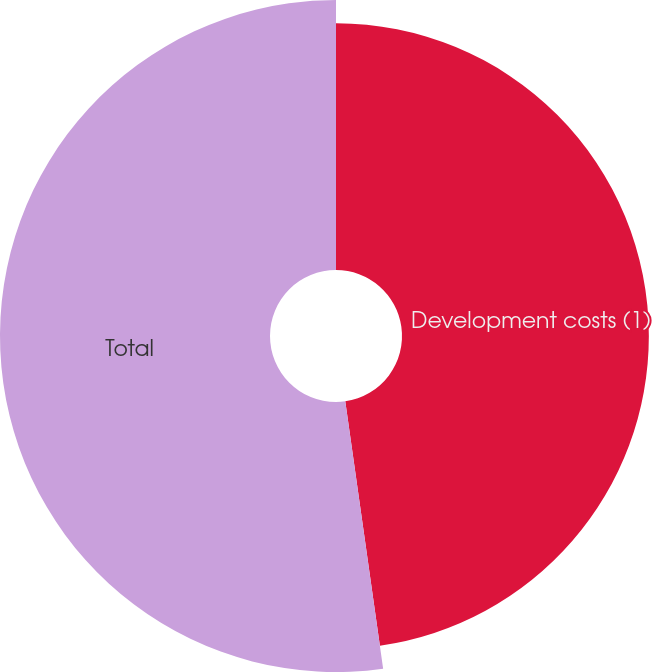Convert chart to OTSL. <chart><loc_0><loc_0><loc_500><loc_500><pie_chart><fcel>Development costs (1)<fcel>Total<nl><fcel>47.76%<fcel>52.24%<nl></chart> 